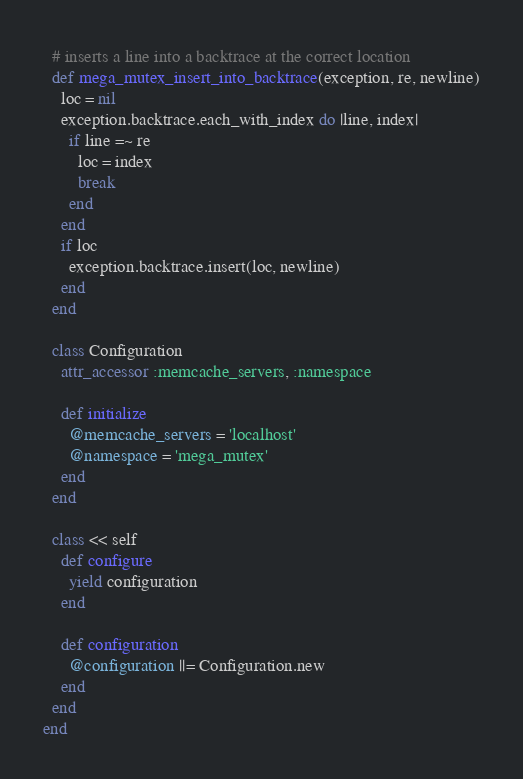<code> <loc_0><loc_0><loc_500><loc_500><_Ruby_>
  # inserts a line into a backtrace at the correct location
  def mega_mutex_insert_into_backtrace(exception, re, newline)
    loc = nil
    exception.backtrace.each_with_index do |line, index|
      if line =~ re
        loc = index
        break
      end
    end
    if loc
      exception.backtrace.insert(loc, newline)
    end
  end
  
  class Configuration
    attr_accessor :memcache_servers, :namespace

    def initialize
      @memcache_servers = 'localhost'
      @namespace = 'mega_mutex'
    end
  end

  class << self
    def configure
      yield configuration
    end

    def configuration
      @configuration ||= Configuration.new
    end
  end
end

</code> 